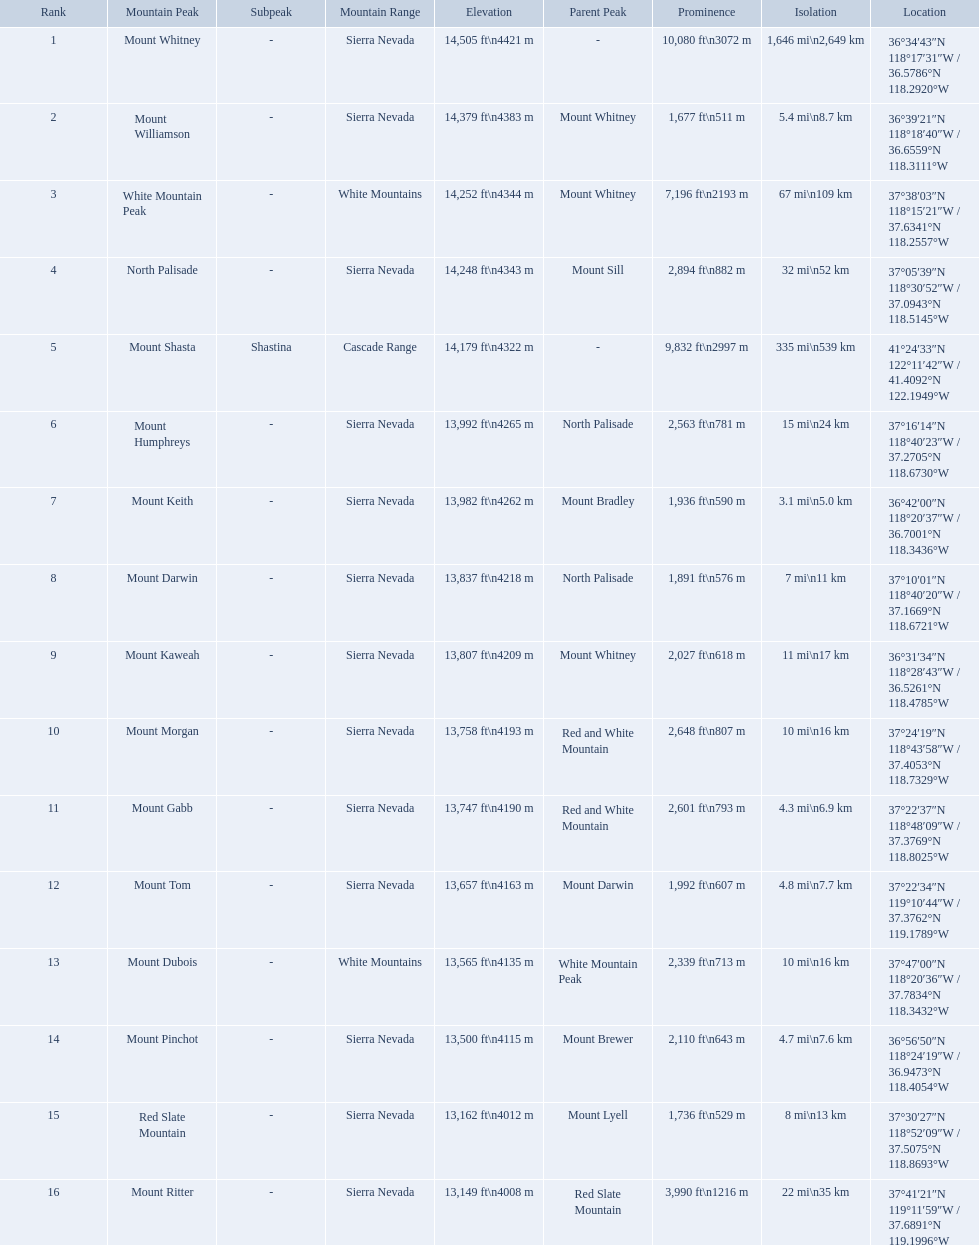Which are the mountain peaks? Mount Whitney, Mount Williamson, White Mountain Peak, North Palisade, Mount Shasta, Mount Humphreys, Mount Keith, Mount Darwin, Mount Kaweah, Mount Morgan, Mount Gabb, Mount Tom, Mount Dubois, Mount Pinchot, Red Slate Mountain, Mount Ritter. Of these, which is in the cascade range? Mount Shasta. What are all of the mountain peaks? Mount Whitney, Mount Williamson, White Mountain Peak, North Palisade, Mount Shasta, Mount Humphreys, Mount Keith, Mount Darwin, Mount Kaweah, Mount Morgan, Mount Gabb, Mount Tom, Mount Dubois, Mount Pinchot, Red Slate Mountain, Mount Ritter. In what ranges are they? Sierra Nevada, Sierra Nevada, White Mountains, Sierra Nevada, Cascade Range, Sierra Nevada, Sierra Nevada, Sierra Nevada, Sierra Nevada, Sierra Nevada, Sierra Nevada, Sierra Nevada, White Mountains, Sierra Nevada, Sierra Nevada, Sierra Nevada. Which peak is in the cascade range? Mount Shasta. What are the prominence lengths higher than 10,000 feet? 10,080 ft\n3072 m. What mountain peak has a prominence of 10,080 feet? Mount Whitney. What are the heights of the californian mountain peaks? 14,505 ft\n4421 m, 14,379 ft\n4383 m, 14,252 ft\n4344 m, 14,248 ft\n4343 m, 14,179 ft\n4322 m, 13,992 ft\n4265 m, 13,982 ft\n4262 m, 13,837 ft\n4218 m, 13,807 ft\n4209 m, 13,758 ft\n4193 m, 13,747 ft\n4190 m, 13,657 ft\n4163 m, 13,565 ft\n4135 m, 13,500 ft\n4115 m, 13,162 ft\n4012 m, 13,149 ft\n4008 m. What elevation is 13,149 ft or less? 13,149 ft\n4008 m. What mountain peak is at this elevation? Mount Ritter. What are the listed elevations? 14,505 ft\n4421 m, 14,379 ft\n4383 m, 14,252 ft\n4344 m, 14,248 ft\n4343 m, 14,179 ft\n4322 m, 13,992 ft\n4265 m, 13,982 ft\n4262 m, 13,837 ft\n4218 m, 13,807 ft\n4209 m, 13,758 ft\n4193 m, 13,747 ft\n4190 m, 13,657 ft\n4163 m, 13,565 ft\n4135 m, 13,500 ft\n4115 m, 13,162 ft\n4012 m, 13,149 ft\n4008 m. Which of those is 13,149 ft or below? 13,149 ft\n4008 m. To what mountain peak does that value correspond? Mount Ritter. Which mountain peaks are lower than 14,000 ft? Mount Humphreys, Mount Keith, Mount Darwin, Mount Kaweah, Mount Morgan, Mount Gabb, Mount Tom, Mount Dubois, Mount Pinchot, Red Slate Mountain, Mount Ritter. Are any of them below 13,500? if so, which ones? Red Slate Mountain, Mount Ritter. What's the lowest peak? 13,149 ft\n4008 m. Which one is that? Mount Ritter. What are all of the peaks? Mount Whitney, Mount Williamson, White Mountain Peak, North Palisade, Mount Shasta, Mount Humphreys, Mount Keith, Mount Darwin, Mount Kaweah, Mount Morgan, Mount Gabb, Mount Tom, Mount Dubois, Mount Pinchot, Red Slate Mountain, Mount Ritter. Where are they located? Sierra Nevada, Sierra Nevada, White Mountains, Sierra Nevada, Cascade Range, Sierra Nevada, Sierra Nevada, Sierra Nevada, Sierra Nevada, Sierra Nevada, Sierra Nevada, Sierra Nevada, White Mountains, Sierra Nevada, Sierra Nevada, Sierra Nevada. How tall are they? 14,505 ft\n4421 m, 14,379 ft\n4383 m, 14,252 ft\n4344 m, 14,248 ft\n4343 m, 14,179 ft\n4322 m, 13,992 ft\n4265 m, 13,982 ft\n4262 m, 13,837 ft\n4218 m, 13,807 ft\n4209 m, 13,758 ft\n4193 m, 13,747 ft\n4190 m, 13,657 ft\n4163 m, 13,565 ft\n4135 m, 13,500 ft\n4115 m, 13,162 ft\n4012 m, 13,149 ft\n4008 m. What about just the peaks in the sierra nevadas? 14,505 ft\n4421 m, 14,379 ft\n4383 m, 14,248 ft\n4343 m, 13,992 ft\n4265 m, 13,982 ft\n4262 m, 13,837 ft\n4218 m, 13,807 ft\n4209 m, 13,758 ft\n4193 m, 13,747 ft\n4190 m, 13,657 ft\n4163 m, 13,500 ft\n4115 m, 13,162 ft\n4012 m, 13,149 ft\n4008 m. And of those, which is the tallest? Mount Whitney. What are all of the mountain peaks? Mount Whitney, Mount Williamson, White Mountain Peak, North Palisade, Mount Shasta, Mount Humphreys, Mount Keith, Mount Darwin, Mount Kaweah, Mount Morgan, Mount Gabb, Mount Tom, Mount Dubois, Mount Pinchot, Red Slate Mountain, Mount Ritter. In what ranges are they located? Sierra Nevada, Sierra Nevada, White Mountains, Sierra Nevada, Cascade Range, Sierra Nevada, Sierra Nevada, Sierra Nevada, Sierra Nevada, Sierra Nevada, Sierra Nevada, Sierra Nevada, White Mountains, Sierra Nevada, Sierra Nevada, Sierra Nevada. Could you parse the entire table? {'header': ['Rank', 'Mountain Peak', 'Subpeak', 'Mountain Range', 'Elevation', 'Parent Peak', 'Prominence', 'Isolation', 'Location'], 'rows': [['1', 'Mount Whitney', '-', 'Sierra Nevada', '14,505\xa0ft\\n4421\xa0m', '-', '10,080\xa0ft\\n3072\xa0m', '1,646\xa0mi\\n2,649\xa0km', '36°34′43″N 118°17′31″W\ufeff / \ufeff36.5786°N 118.2920°W'], ['2', 'Mount Williamson', '-', 'Sierra Nevada', '14,379\xa0ft\\n4383\xa0m', 'Mount Whitney', '1,677\xa0ft\\n511\xa0m', '5.4\xa0mi\\n8.7\xa0km', '36°39′21″N 118°18′40″W\ufeff / \ufeff36.6559°N 118.3111°W'], ['3', 'White Mountain Peak', '-', 'White Mountains', '14,252\xa0ft\\n4344\xa0m', 'Mount Whitney', '7,196\xa0ft\\n2193\xa0m', '67\xa0mi\\n109\xa0km', '37°38′03″N 118°15′21″W\ufeff / \ufeff37.6341°N 118.2557°W'], ['4', 'North Palisade', '-', 'Sierra Nevada', '14,248\xa0ft\\n4343\xa0m', 'Mount Sill', '2,894\xa0ft\\n882\xa0m', '32\xa0mi\\n52\xa0km', '37°05′39″N 118°30′52″W\ufeff / \ufeff37.0943°N 118.5145°W'], ['5', 'Mount Shasta', 'Shastina', 'Cascade Range', '14,179\xa0ft\\n4322\xa0m', '-', '9,832\xa0ft\\n2997\xa0m', '335\xa0mi\\n539\xa0km', '41°24′33″N 122°11′42″W\ufeff / \ufeff41.4092°N 122.1949°W'], ['6', 'Mount Humphreys', '-', 'Sierra Nevada', '13,992\xa0ft\\n4265\xa0m', 'North Palisade', '2,563\xa0ft\\n781\xa0m', '15\xa0mi\\n24\xa0km', '37°16′14″N 118°40′23″W\ufeff / \ufeff37.2705°N 118.6730°W'], ['7', 'Mount Keith', '-', 'Sierra Nevada', '13,982\xa0ft\\n4262\xa0m', 'Mount Bradley', '1,936\xa0ft\\n590\xa0m', '3.1\xa0mi\\n5.0\xa0km', '36°42′00″N 118°20′37″W\ufeff / \ufeff36.7001°N 118.3436°W'], ['8', 'Mount Darwin', '-', 'Sierra Nevada', '13,837\xa0ft\\n4218\xa0m', 'North Palisade', '1,891\xa0ft\\n576\xa0m', '7\xa0mi\\n11\xa0km', '37°10′01″N 118°40′20″W\ufeff / \ufeff37.1669°N 118.6721°W'], ['9', 'Mount Kaweah', '-', 'Sierra Nevada', '13,807\xa0ft\\n4209\xa0m', 'Mount Whitney', '2,027\xa0ft\\n618\xa0m', '11\xa0mi\\n17\xa0km', '36°31′34″N 118°28′43″W\ufeff / \ufeff36.5261°N 118.4785°W'], ['10', 'Mount Morgan', '-', 'Sierra Nevada', '13,758\xa0ft\\n4193\xa0m', 'Red and White Mountain', '2,648\xa0ft\\n807\xa0m', '10\xa0mi\\n16\xa0km', '37°24′19″N 118°43′58″W\ufeff / \ufeff37.4053°N 118.7329°W'], ['11', 'Mount Gabb', '-', 'Sierra Nevada', '13,747\xa0ft\\n4190\xa0m', 'Red and White Mountain', '2,601\xa0ft\\n793\xa0m', '4.3\xa0mi\\n6.9\xa0km', '37°22′37″N 118°48′09″W\ufeff / \ufeff37.3769°N 118.8025°W'], ['12', 'Mount Tom', '-', 'Sierra Nevada', '13,657\xa0ft\\n4163\xa0m', 'Mount Darwin', '1,992\xa0ft\\n607\xa0m', '4.8\xa0mi\\n7.7\xa0km', '37°22′34″N 119°10′44″W\ufeff / \ufeff37.3762°N 119.1789°W'], ['13', 'Mount Dubois', '-', 'White Mountains', '13,565\xa0ft\\n4135\xa0m', 'White Mountain Peak', '2,339\xa0ft\\n713\xa0m', '10\xa0mi\\n16\xa0km', '37°47′00″N 118°20′36″W\ufeff / \ufeff37.7834°N 118.3432°W'], ['14', 'Mount Pinchot', '-', 'Sierra Nevada', '13,500\xa0ft\\n4115\xa0m', 'Mount Brewer', '2,110\xa0ft\\n643\xa0m', '4.7\xa0mi\\n7.6\xa0km', '36°56′50″N 118°24′19″W\ufeff / \ufeff36.9473°N 118.4054°W'], ['15', 'Red Slate Mountain', '-', 'Sierra Nevada', '13,162\xa0ft\\n4012\xa0m', 'Mount Lyell', '1,736\xa0ft\\n529\xa0m', '8\xa0mi\\n13\xa0km', '37°30′27″N 118°52′09″W\ufeff / \ufeff37.5075°N 118.8693°W'], ['16', 'Mount Ritter', '-', 'Sierra Nevada', '13,149\xa0ft\\n4008\xa0m', 'Red Slate Mountain', '3,990\xa0ft\\n1216\xa0m', '22\xa0mi\\n35\xa0km', '37°41′21″N 119°11′59″W\ufeff / \ufeff37.6891°N 119.1996°W']]} And which mountain peak is in the cascade range? Mount Shasta. 